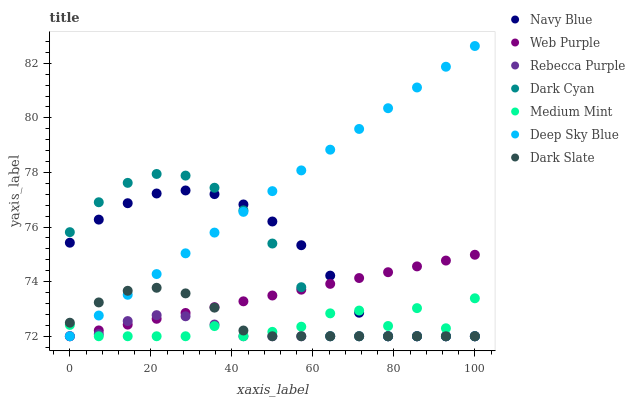Does Rebecca Purple have the minimum area under the curve?
Answer yes or no. Yes. Does Deep Sky Blue have the maximum area under the curve?
Answer yes or no. Yes. Does Navy Blue have the minimum area under the curve?
Answer yes or no. No. Does Navy Blue have the maximum area under the curve?
Answer yes or no. No. Is Web Purple the smoothest?
Answer yes or no. Yes. Is Medium Mint the roughest?
Answer yes or no. Yes. Is Navy Blue the smoothest?
Answer yes or no. No. Is Navy Blue the roughest?
Answer yes or no. No. Does Medium Mint have the lowest value?
Answer yes or no. Yes. Does Deep Sky Blue have the highest value?
Answer yes or no. Yes. Does Navy Blue have the highest value?
Answer yes or no. No. Does Deep Sky Blue intersect Dark Cyan?
Answer yes or no. Yes. Is Deep Sky Blue less than Dark Cyan?
Answer yes or no. No. Is Deep Sky Blue greater than Dark Cyan?
Answer yes or no. No. 